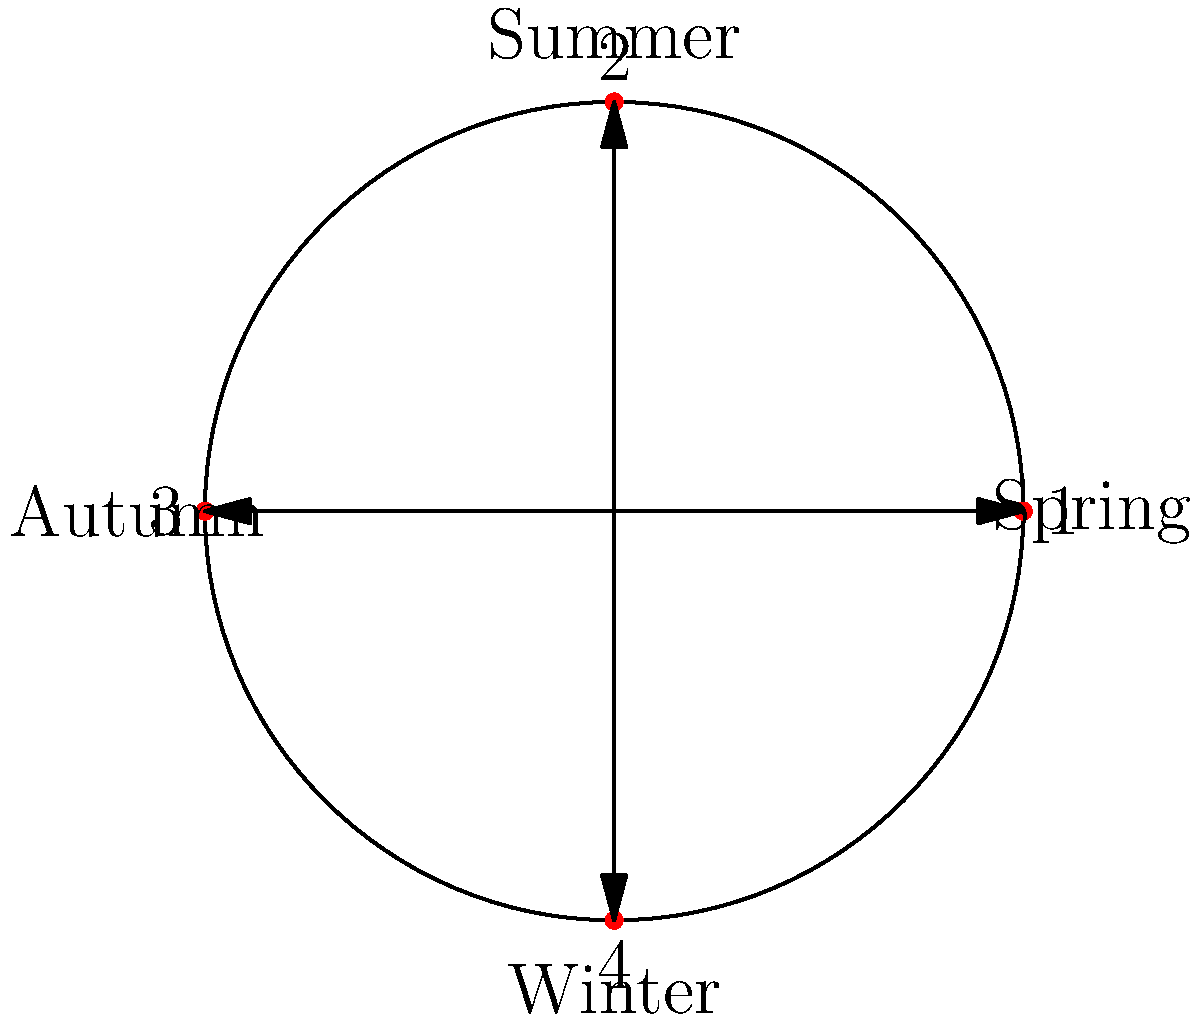As a community activist focusing on environmental issues, you're analyzing the cyclic patterns of local wildlife populations in Arun District. The circular diagram represents the seasonal cycle and population peaks of a particular species. If the current population peak is at position 1 (Spring), and the species typically experiences two population peaks per year, at which position will the next peak occur? To solve this problem, we need to follow these steps:

1. Understand the diagram:
   - The circle represents a full year cycle.
   - It's divided into four seasons: Spring (1), Summer (2), Autumn (3), and Winter (4).

2. Analyze the given information:
   - The current peak is at position 1 (Spring).
   - The species has two population peaks per year.

3. Calculate the next peak:
   - With two peaks per year, they would be approximately 6 months apart.
   - In a circular diagram with 4 positions, this translates to a rotation of 180 degrees or 2 positions.

4. Determine the next peak position:
   - Starting from position 1 (Spring) and moving 2 positions clockwise, we arrive at position 3 (Autumn).

Therefore, the next population peak will occur at position 3, which corresponds to Autumn.
Answer: 3 (Autumn) 